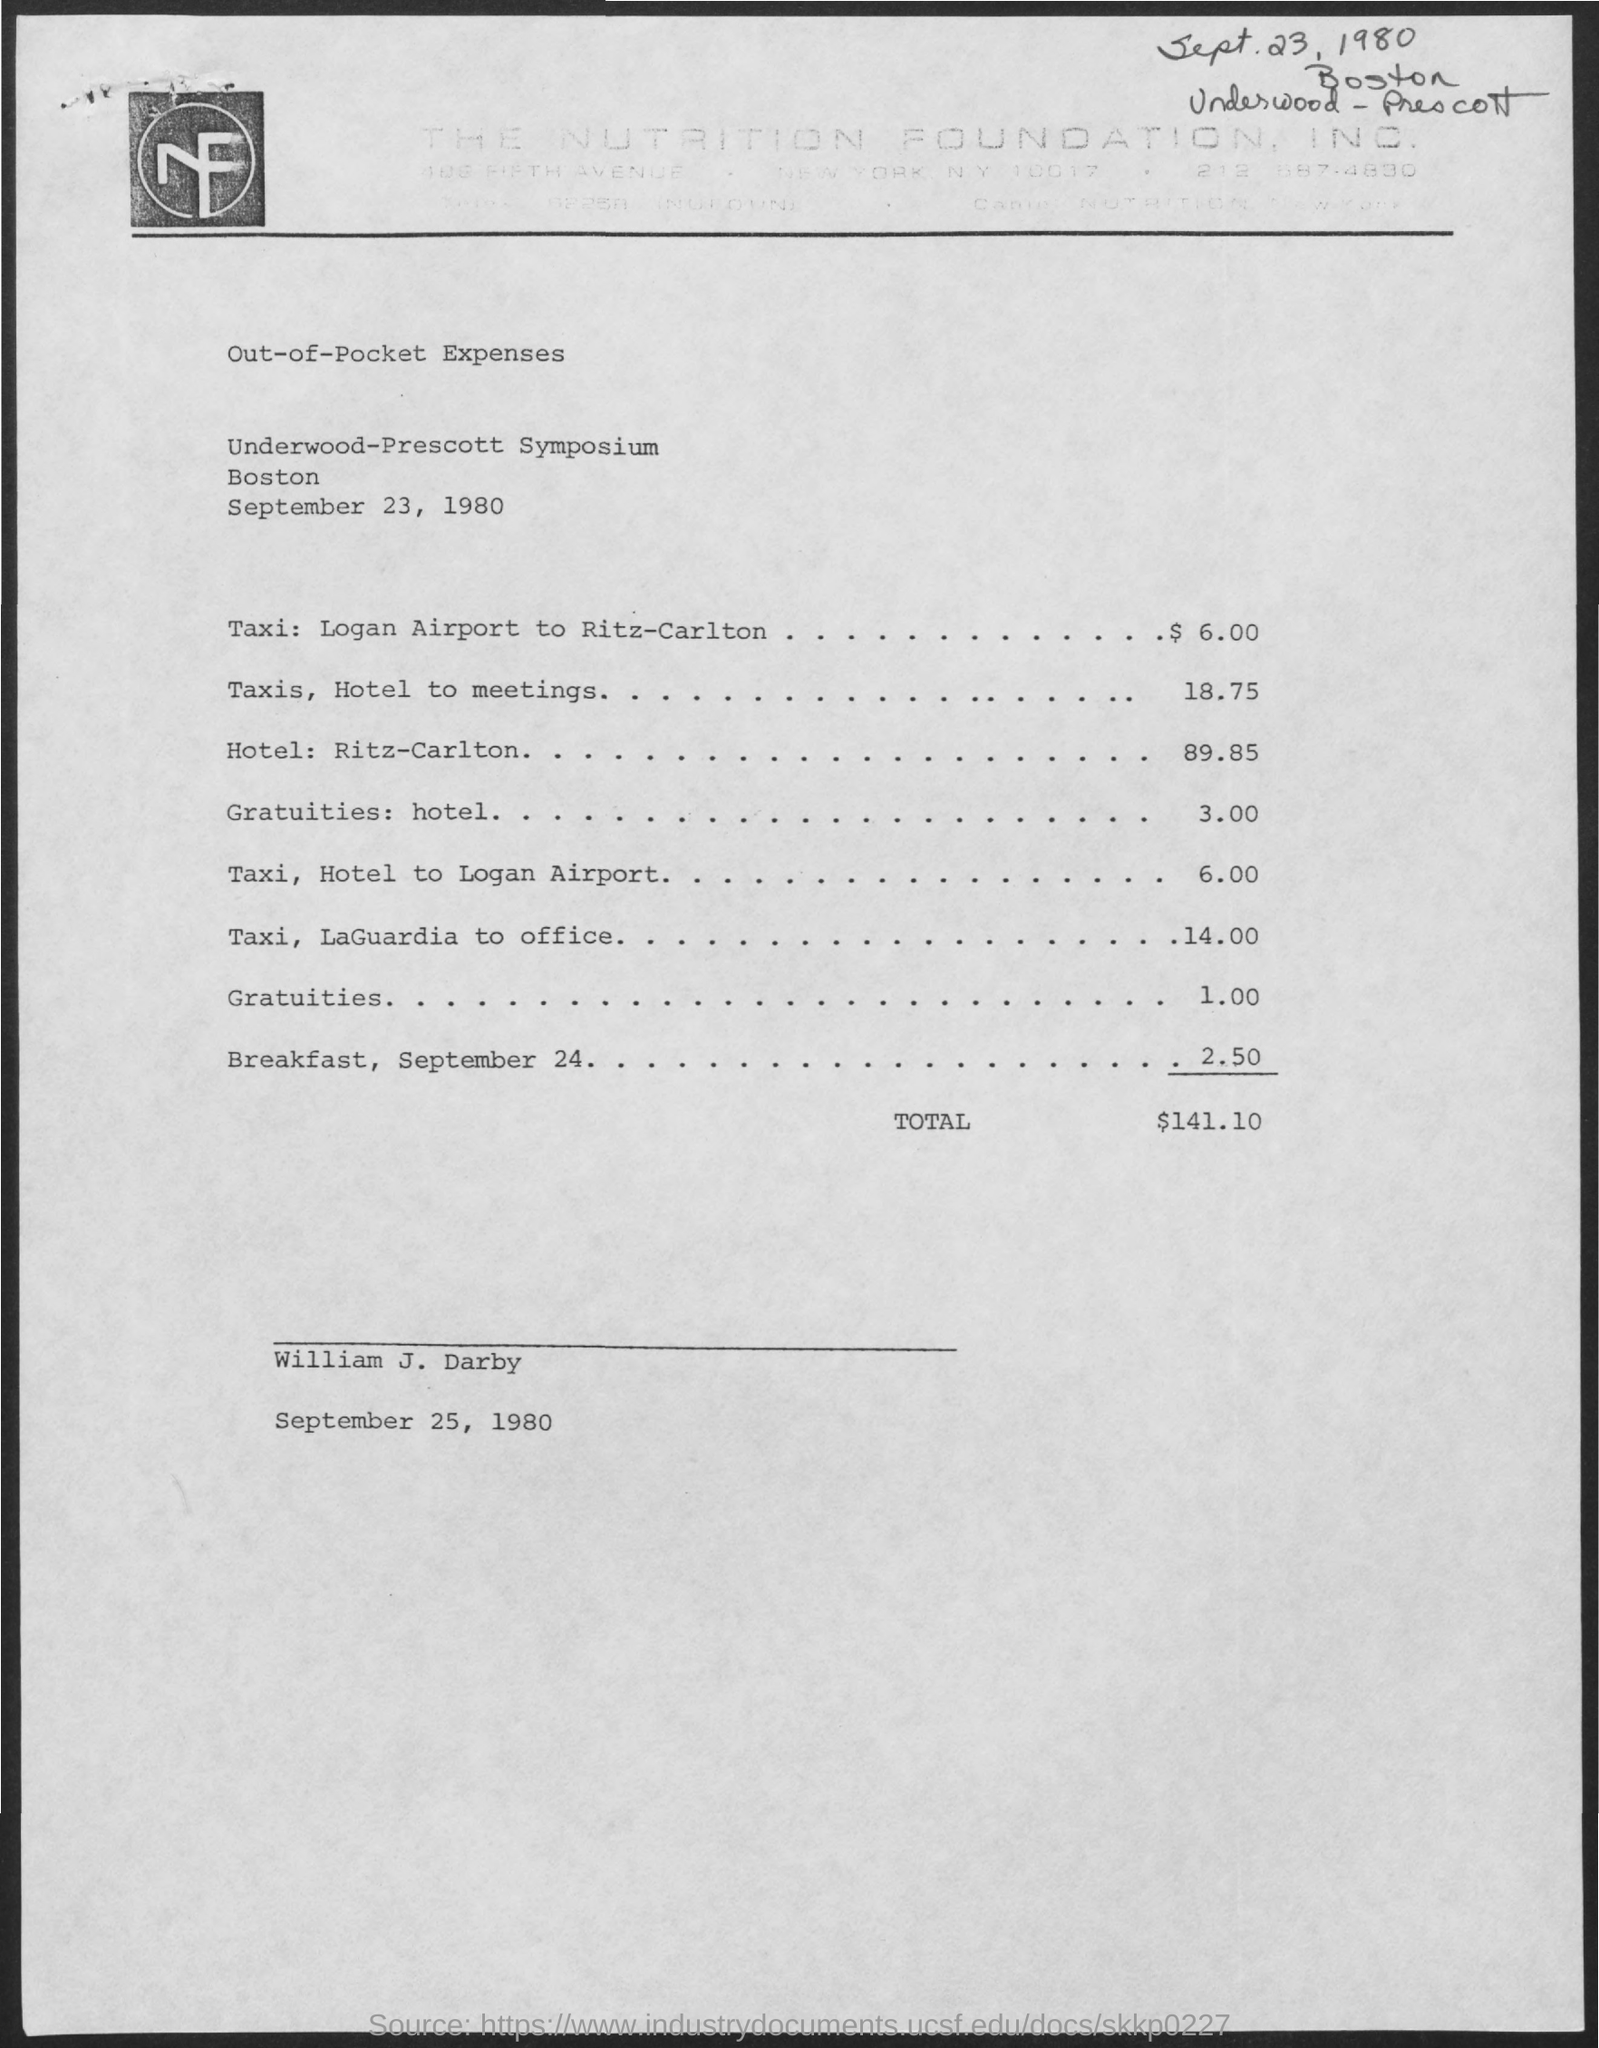What event does this document relate to? The document relates to the 'Underwood-Prescott Symposium' which took place in Boston on September 23, 1980. Can you tell me the total out-of-pocket expenses listed? The total out-of-pocket expenses listed on the document sum up to $141.10. 